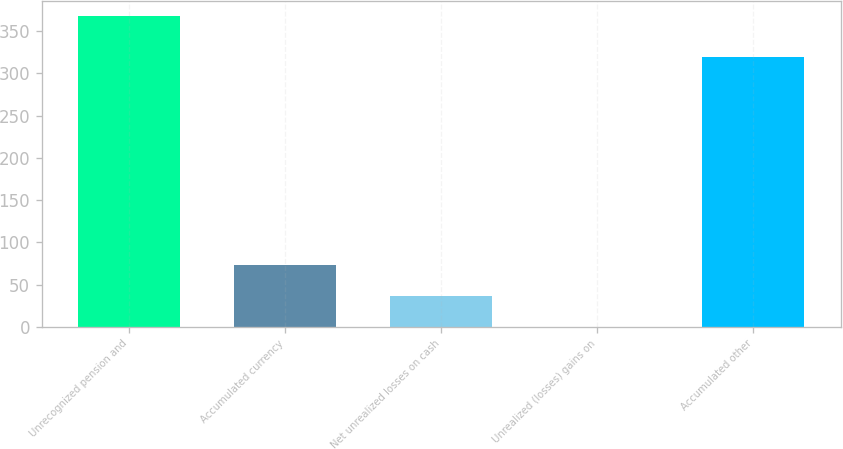Convert chart. <chart><loc_0><loc_0><loc_500><loc_500><bar_chart><fcel>Unrecognized pension and<fcel>Accumulated currency<fcel>Net unrealized losses on cash<fcel>Unrealized (losses) gains on<fcel>Accumulated other<nl><fcel>368<fcel>73.68<fcel>36.89<fcel>0.1<fcel>319<nl></chart> 